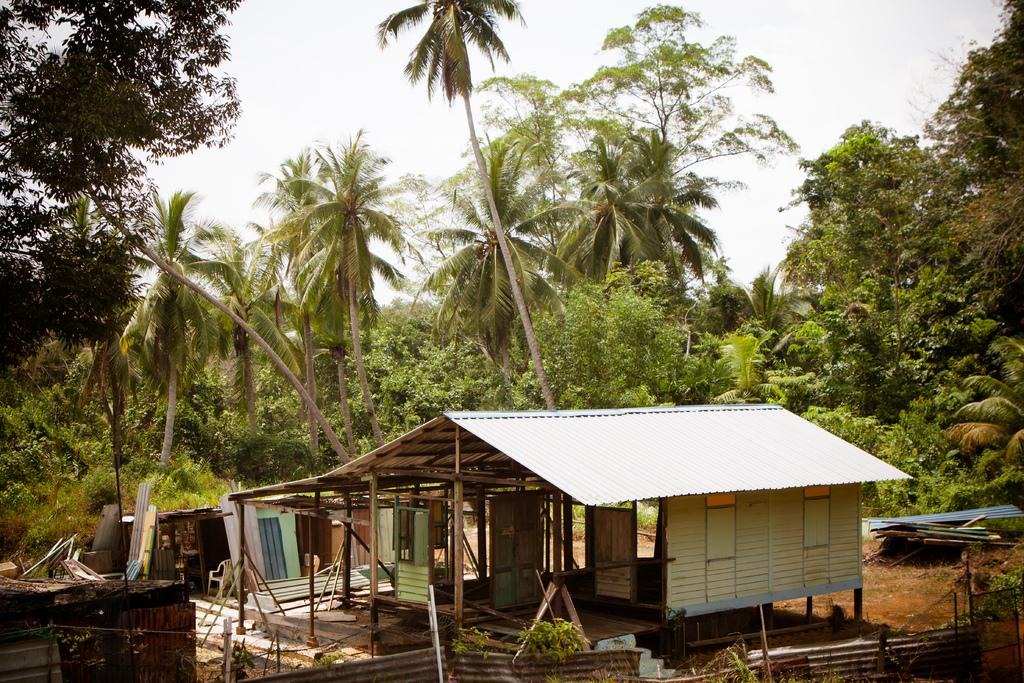What type of structure is present in the image? There is a shed in the image. What other natural elements can be seen in the image? There are trees in the image. What is visible at the top of the image? The sky is visible at the top of the image. How many roses are growing in the yard in the image? There are no roses or yards mentioned in the image; it only features a shed, trees, and the sky. 